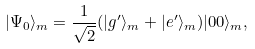<formula> <loc_0><loc_0><loc_500><loc_500>| \Psi _ { 0 } \rangle _ { m } = \frac { 1 } { \sqrt { 2 } } ( | g ^ { \prime } \rangle _ { m } + | e ^ { \prime } \rangle _ { m } ) | 0 0 \rangle _ { m } ,</formula> 